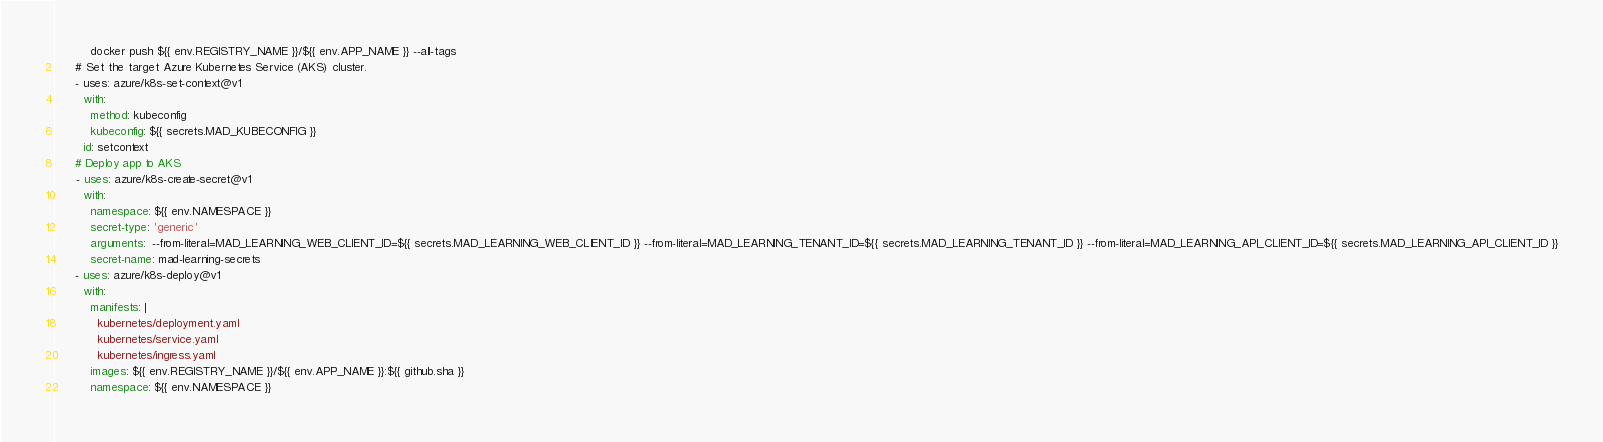<code> <loc_0><loc_0><loc_500><loc_500><_YAML_>          docker push ${{ env.REGISTRY_NAME }}/${{ env.APP_NAME }} --all-tags
      # Set the target Azure Kubernetes Service (AKS) cluster. 
      - uses: azure/k8s-set-context@v1
        with:
          method: kubeconfig
          kubeconfig: ${{ secrets.MAD_KUBECONFIG }}
        id: setcontext
      # Deploy app to AKS
      - uses: azure/k8s-create-secret@v1
        with:
          namespace: ${{ env.NAMESPACE }}
          secret-type: 'generic'
          arguments:  --from-literal=MAD_LEARNING_WEB_CLIENT_ID=${{ secrets.MAD_LEARNING_WEB_CLIENT_ID }} --from-literal=MAD_LEARNING_TENANT_ID=${{ secrets.MAD_LEARNING_TENANT_ID }} --from-literal=MAD_LEARNING_API_CLIENT_ID=${{ secrets.MAD_LEARNING_API_CLIENT_ID }}
          secret-name: mad-learning-secrets
      - uses: azure/k8s-deploy@v1
        with:
          manifests: |
            kubernetes/deployment.yaml
            kubernetes/service.yaml
            kubernetes/ingress.yaml
          images: ${{ env.REGISTRY_NAME }}/${{ env.APP_NAME }}:${{ github.sha }}
          namespace: ${{ env.NAMESPACE }}</code> 